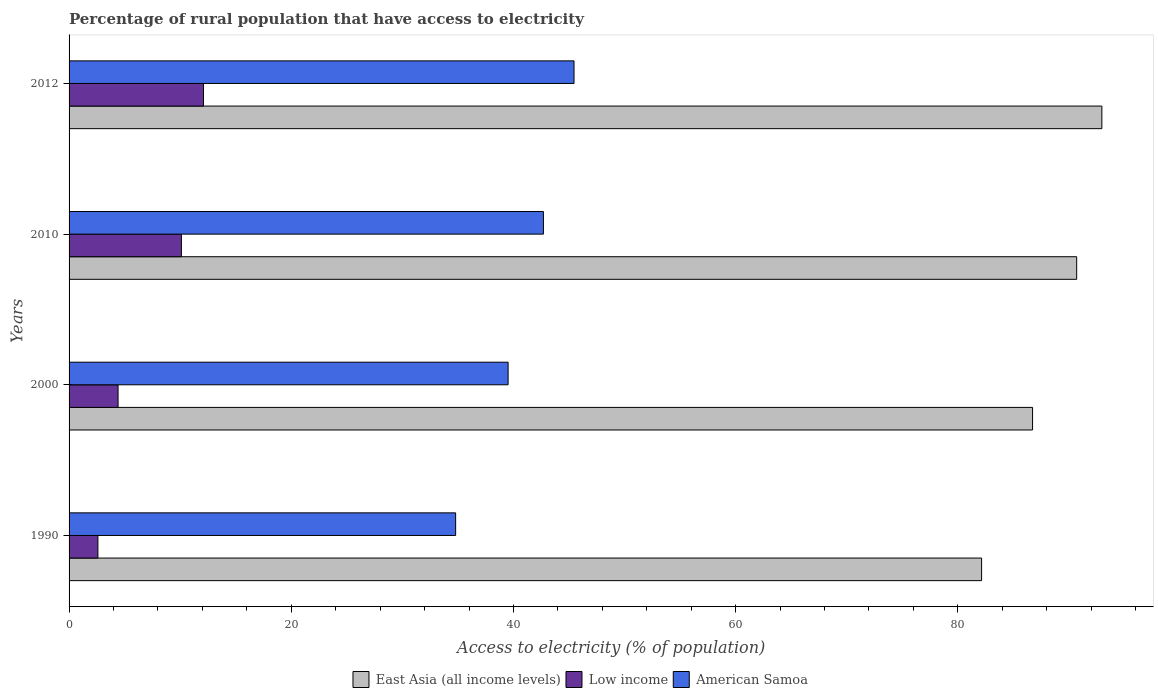How many bars are there on the 4th tick from the top?
Your answer should be very brief. 3. How many bars are there on the 1st tick from the bottom?
Offer a very short reply. 3. What is the label of the 3rd group of bars from the top?
Your response must be concise. 2000. In how many cases, is the number of bars for a given year not equal to the number of legend labels?
Your response must be concise. 0. What is the percentage of rural population that have access to electricity in American Samoa in 1990?
Keep it short and to the point. 34.8. Across all years, what is the maximum percentage of rural population that have access to electricity in Low income?
Your response must be concise. 12.1. Across all years, what is the minimum percentage of rural population that have access to electricity in American Samoa?
Your answer should be compact. 34.8. In which year was the percentage of rural population that have access to electricity in American Samoa maximum?
Offer a very short reply. 2012. In which year was the percentage of rural population that have access to electricity in American Samoa minimum?
Your answer should be very brief. 1990. What is the total percentage of rural population that have access to electricity in American Samoa in the graph?
Make the answer very short. 162.47. What is the difference between the percentage of rural population that have access to electricity in American Samoa in 1990 and that in 2010?
Provide a short and direct response. -7.9. What is the difference between the percentage of rural population that have access to electricity in East Asia (all income levels) in 2000 and the percentage of rural population that have access to electricity in Low income in 2012?
Ensure brevity in your answer.  74.63. What is the average percentage of rural population that have access to electricity in American Samoa per year?
Keep it short and to the point. 40.62. In the year 1990, what is the difference between the percentage of rural population that have access to electricity in Low income and percentage of rural population that have access to electricity in East Asia (all income levels)?
Your answer should be compact. -79.55. In how many years, is the percentage of rural population that have access to electricity in Low income greater than 28 %?
Provide a succinct answer. 0. What is the ratio of the percentage of rural population that have access to electricity in American Samoa in 2010 to that in 2012?
Provide a succinct answer. 0.94. What is the difference between the highest and the second highest percentage of rural population that have access to electricity in American Samoa?
Make the answer very short. 2.75. What is the difference between the highest and the lowest percentage of rural population that have access to electricity in Low income?
Give a very brief answer. 9.5. In how many years, is the percentage of rural population that have access to electricity in East Asia (all income levels) greater than the average percentage of rural population that have access to electricity in East Asia (all income levels) taken over all years?
Keep it short and to the point. 2. What does the 3rd bar from the bottom in 2010 represents?
Make the answer very short. American Samoa. How many years are there in the graph?
Your answer should be very brief. 4. What is the difference between two consecutive major ticks on the X-axis?
Keep it short and to the point. 20. Are the values on the major ticks of X-axis written in scientific E-notation?
Your answer should be very brief. No. Where does the legend appear in the graph?
Your answer should be compact. Bottom center. How many legend labels are there?
Provide a short and direct response. 3. How are the legend labels stacked?
Your answer should be very brief. Horizontal. What is the title of the graph?
Provide a short and direct response. Percentage of rural population that have access to electricity. What is the label or title of the X-axis?
Your answer should be compact. Access to electricity (% of population). What is the Access to electricity (% of population) of East Asia (all income levels) in 1990?
Give a very brief answer. 82.14. What is the Access to electricity (% of population) in Low income in 1990?
Your answer should be compact. 2.6. What is the Access to electricity (% of population) in American Samoa in 1990?
Provide a short and direct response. 34.8. What is the Access to electricity (% of population) in East Asia (all income levels) in 2000?
Provide a succinct answer. 86.73. What is the Access to electricity (% of population) of Low income in 2000?
Provide a short and direct response. 4.41. What is the Access to electricity (% of population) in American Samoa in 2000?
Make the answer very short. 39.52. What is the Access to electricity (% of population) of East Asia (all income levels) in 2010?
Make the answer very short. 90.7. What is the Access to electricity (% of population) of Low income in 2010?
Offer a terse response. 10.11. What is the Access to electricity (% of population) in American Samoa in 2010?
Give a very brief answer. 42.7. What is the Access to electricity (% of population) of East Asia (all income levels) in 2012?
Your answer should be compact. 92.97. What is the Access to electricity (% of population) in Low income in 2012?
Your answer should be very brief. 12.1. What is the Access to electricity (% of population) of American Samoa in 2012?
Provide a short and direct response. 45.45. Across all years, what is the maximum Access to electricity (% of population) in East Asia (all income levels)?
Provide a succinct answer. 92.97. Across all years, what is the maximum Access to electricity (% of population) in Low income?
Give a very brief answer. 12.1. Across all years, what is the maximum Access to electricity (% of population) of American Samoa?
Your response must be concise. 45.45. Across all years, what is the minimum Access to electricity (% of population) in East Asia (all income levels)?
Ensure brevity in your answer.  82.14. Across all years, what is the minimum Access to electricity (% of population) in Low income?
Your answer should be compact. 2.6. Across all years, what is the minimum Access to electricity (% of population) of American Samoa?
Give a very brief answer. 34.8. What is the total Access to electricity (% of population) of East Asia (all income levels) in the graph?
Make the answer very short. 352.54. What is the total Access to electricity (% of population) of Low income in the graph?
Keep it short and to the point. 29.21. What is the total Access to electricity (% of population) in American Samoa in the graph?
Your answer should be very brief. 162.47. What is the difference between the Access to electricity (% of population) in East Asia (all income levels) in 1990 and that in 2000?
Provide a short and direct response. -4.59. What is the difference between the Access to electricity (% of population) of Low income in 1990 and that in 2000?
Offer a terse response. -1.82. What is the difference between the Access to electricity (% of population) of American Samoa in 1990 and that in 2000?
Offer a very short reply. -4.72. What is the difference between the Access to electricity (% of population) of East Asia (all income levels) in 1990 and that in 2010?
Your answer should be very brief. -8.56. What is the difference between the Access to electricity (% of population) of Low income in 1990 and that in 2010?
Provide a succinct answer. -7.52. What is the difference between the Access to electricity (% of population) of American Samoa in 1990 and that in 2010?
Ensure brevity in your answer.  -7.9. What is the difference between the Access to electricity (% of population) of East Asia (all income levels) in 1990 and that in 2012?
Provide a short and direct response. -10.83. What is the difference between the Access to electricity (% of population) in Low income in 1990 and that in 2012?
Ensure brevity in your answer.  -9.5. What is the difference between the Access to electricity (% of population) in American Samoa in 1990 and that in 2012?
Offer a terse response. -10.66. What is the difference between the Access to electricity (% of population) of East Asia (all income levels) in 2000 and that in 2010?
Your answer should be compact. -3.97. What is the difference between the Access to electricity (% of population) of Low income in 2000 and that in 2010?
Give a very brief answer. -5.7. What is the difference between the Access to electricity (% of population) of American Samoa in 2000 and that in 2010?
Keep it short and to the point. -3.18. What is the difference between the Access to electricity (% of population) of East Asia (all income levels) in 2000 and that in 2012?
Give a very brief answer. -6.24. What is the difference between the Access to electricity (% of population) in Low income in 2000 and that in 2012?
Make the answer very short. -7.69. What is the difference between the Access to electricity (% of population) in American Samoa in 2000 and that in 2012?
Keep it short and to the point. -5.93. What is the difference between the Access to electricity (% of population) in East Asia (all income levels) in 2010 and that in 2012?
Give a very brief answer. -2.27. What is the difference between the Access to electricity (% of population) in Low income in 2010 and that in 2012?
Give a very brief answer. -1.98. What is the difference between the Access to electricity (% of population) in American Samoa in 2010 and that in 2012?
Your response must be concise. -2.75. What is the difference between the Access to electricity (% of population) in East Asia (all income levels) in 1990 and the Access to electricity (% of population) in Low income in 2000?
Make the answer very short. 77.73. What is the difference between the Access to electricity (% of population) of East Asia (all income levels) in 1990 and the Access to electricity (% of population) of American Samoa in 2000?
Ensure brevity in your answer.  42.62. What is the difference between the Access to electricity (% of population) of Low income in 1990 and the Access to electricity (% of population) of American Samoa in 2000?
Ensure brevity in your answer.  -36.93. What is the difference between the Access to electricity (% of population) of East Asia (all income levels) in 1990 and the Access to electricity (% of population) of Low income in 2010?
Keep it short and to the point. 72.03. What is the difference between the Access to electricity (% of population) in East Asia (all income levels) in 1990 and the Access to electricity (% of population) in American Samoa in 2010?
Offer a very short reply. 39.44. What is the difference between the Access to electricity (% of population) in Low income in 1990 and the Access to electricity (% of population) in American Samoa in 2010?
Offer a very short reply. -40.1. What is the difference between the Access to electricity (% of population) in East Asia (all income levels) in 1990 and the Access to electricity (% of population) in Low income in 2012?
Make the answer very short. 70.05. What is the difference between the Access to electricity (% of population) of East Asia (all income levels) in 1990 and the Access to electricity (% of population) of American Samoa in 2012?
Your response must be concise. 36.69. What is the difference between the Access to electricity (% of population) in Low income in 1990 and the Access to electricity (% of population) in American Samoa in 2012?
Keep it short and to the point. -42.86. What is the difference between the Access to electricity (% of population) in East Asia (all income levels) in 2000 and the Access to electricity (% of population) in Low income in 2010?
Offer a very short reply. 76.62. What is the difference between the Access to electricity (% of population) of East Asia (all income levels) in 2000 and the Access to electricity (% of population) of American Samoa in 2010?
Offer a terse response. 44.03. What is the difference between the Access to electricity (% of population) in Low income in 2000 and the Access to electricity (% of population) in American Samoa in 2010?
Your answer should be compact. -38.29. What is the difference between the Access to electricity (% of population) in East Asia (all income levels) in 2000 and the Access to electricity (% of population) in Low income in 2012?
Keep it short and to the point. 74.63. What is the difference between the Access to electricity (% of population) of East Asia (all income levels) in 2000 and the Access to electricity (% of population) of American Samoa in 2012?
Provide a succinct answer. 41.28. What is the difference between the Access to electricity (% of population) of Low income in 2000 and the Access to electricity (% of population) of American Samoa in 2012?
Offer a very short reply. -41.04. What is the difference between the Access to electricity (% of population) of East Asia (all income levels) in 2010 and the Access to electricity (% of population) of Low income in 2012?
Offer a terse response. 78.61. What is the difference between the Access to electricity (% of population) in East Asia (all income levels) in 2010 and the Access to electricity (% of population) in American Samoa in 2012?
Your response must be concise. 45.25. What is the difference between the Access to electricity (% of population) of Low income in 2010 and the Access to electricity (% of population) of American Samoa in 2012?
Offer a terse response. -35.34. What is the average Access to electricity (% of population) of East Asia (all income levels) per year?
Provide a short and direct response. 88.14. What is the average Access to electricity (% of population) in Low income per year?
Provide a short and direct response. 7.3. What is the average Access to electricity (% of population) in American Samoa per year?
Provide a short and direct response. 40.62. In the year 1990, what is the difference between the Access to electricity (% of population) of East Asia (all income levels) and Access to electricity (% of population) of Low income?
Your answer should be compact. 79.55. In the year 1990, what is the difference between the Access to electricity (% of population) of East Asia (all income levels) and Access to electricity (% of population) of American Samoa?
Provide a succinct answer. 47.34. In the year 1990, what is the difference between the Access to electricity (% of population) in Low income and Access to electricity (% of population) in American Samoa?
Your response must be concise. -32.2. In the year 2000, what is the difference between the Access to electricity (% of population) in East Asia (all income levels) and Access to electricity (% of population) in Low income?
Provide a short and direct response. 82.32. In the year 2000, what is the difference between the Access to electricity (% of population) in East Asia (all income levels) and Access to electricity (% of population) in American Samoa?
Keep it short and to the point. 47.21. In the year 2000, what is the difference between the Access to electricity (% of population) of Low income and Access to electricity (% of population) of American Samoa?
Provide a short and direct response. -35.11. In the year 2010, what is the difference between the Access to electricity (% of population) of East Asia (all income levels) and Access to electricity (% of population) of Low income?
Provide a short and direct response. 80.59. In the year 2010, what is the difference between the Access to electricity (% of population) of East Asia (all income levels) and Access to electricity (% of population) of American Samoa?
Make the answer very short. 48. In the year 2010, what is the difference between the Access to electricity (% of population) of Low income and Access to electricity (% of population) of American Samoa?
Provide a succinct answer. -32.59. In the year 2012, what is the difference between the Access to electricity (% of population) of East Asia (all income levels) and Access to electricity (% of population) of Low income?
Give a very brief answer. 80.87. In the year 2012, what is the difference between the Access to electricity (% of population) in East Asia (all income levels) and Access to electricity (% of population) in American Samoa?
Offer a very short reply. 47.51. In the year 2012, what is the difference between the Access to electricity (% of population) in Low income and Access to electricity (% of population) in American Samoa?
Give a very brief answer. -33.36. What is the ratio of the Access to electricity (% of population) in East Asia (all income levels) in 1990 to that in 2000?
Keep it short and to the point. 0.95. What is the ratio of the Access to electricity (% of population) of Low income in 1990 to that in 2000?
Provide a short and direct response. 0.59. What is the ratio of the Access to electricity (% of population) of American Samoa in 1990 to that in 2000?
Offer a very short reply. 0.88. What is the ratio of the Access to electricity (% of population) of East Asia (all income levels) in 1990 to that in 2010?
Provide a short and direct response. 0.91. What is the ratio of the Access to electricity (% of population) in Low income in 1990 to that in 2010?
Offer a very short reply. 0.26. What is the ratio of the Access to electricity (% of population) in American Samoa in 1990 to that in 2010?
Your answer should be compact. 0.81. What is the ratio of the Access to electricity (% of population) in East Asia (all income levels) in 1990 to that in 2012?
Your answer should be compact. 0.88. What is the ratio of the Access to electricity (% of population) in Low income in 1990 to that in 2012?
Ensure brevity in your answer.  0.21. What is the ratio of the Access to electricity (% of population) in American Samoa in 1990 to that in 2012?
Offer a very short reply. 0.77. What is the ratio of the Access to electricity (% of population) in East Asia (all income levels) in 2000 to that in 2010?
Give a very brief answer. 0.96. What is the ratio of the Access to electricity (% of population) in Low income in 2000 to that in 2010?
Ensure brevity in your answer.  0.44. What is the ratio of the Access to electricity (% of population) of American Samoa in 2000 to that in 2010?
Offer a terse response. 0.93. What is the ratio of the Access to electricity (% of population) of East Asia (all income levels) in 2000 to that in 2012?
Ensure brevity in your answer.  0.93. What is the ratio of the Access to electricity (% of population) of Low income in 2000 to that in 2012?
Offer a terse response. 0.36. What is the ratio of the Access to electricity (% of population) in American Samoa in 2000 to that in 2012?
Keep it short and to the point. 0.87. What is the ratio of the Access to electricity (% of population) in East Asia (all income levels) in 2010 to that in 2012?
Your answer should be very brief. 0.98. What is the ratio of the Access to electricity (% of population) in Low income in 2010 to that in 2012?
Offer a very short reply. 0.84. What is the ratio of the Access to electricity (% of population) of American Samoa in 2010 to that in 2012?
Make the answer very short. 0.94. What is the difference between the highest and the second highest Access to electricity (% of population) in East Asia (all income levels)?
Give a very brief answer. 2.27. What is the difference between the highest and the second highest Access to electricity (% of population) of Low income?
Your answer should be very brief. 1.98. What is the difference between the highest and the second highest Access to electricity (% of population) of American Samoa?
Provide a succinct answer. 2.75. What is the difference between the highest and the lowest Access to electricity (% of population) in East Asia (all income levels)?
Your answer should be very brief. 10.83. What is the difference between the highest and the lowest Access to electricity (% of population) of Low income?
Offer a terse response. 9.5. What is the difference between the highest and the lowest Access to electricity (% of population) in American Samoa?
Your response must be concise. 10.66. 